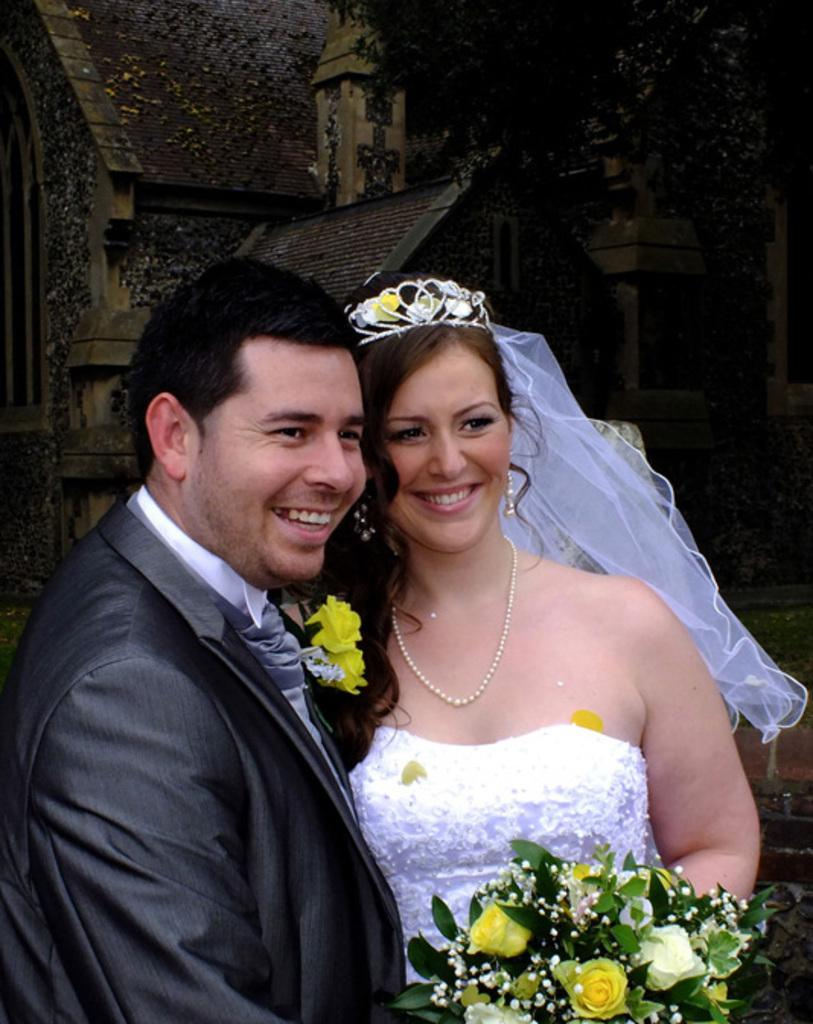Who is the main subject in the image? There is a bridegroom in the image. What is the expression on the bridegroom's face? The bridegroom is smiling. Who is the other person in the image? There is a bride in the image. What is the bride holding? The bride is holding a bouquet. What can be seen in the background of the image? There is a building and a roof visible in the background of the image. What type of underwear is the bridegroom wearing in the image? There is no information about the bridegroom's underwear in the image, and it is not visible. 